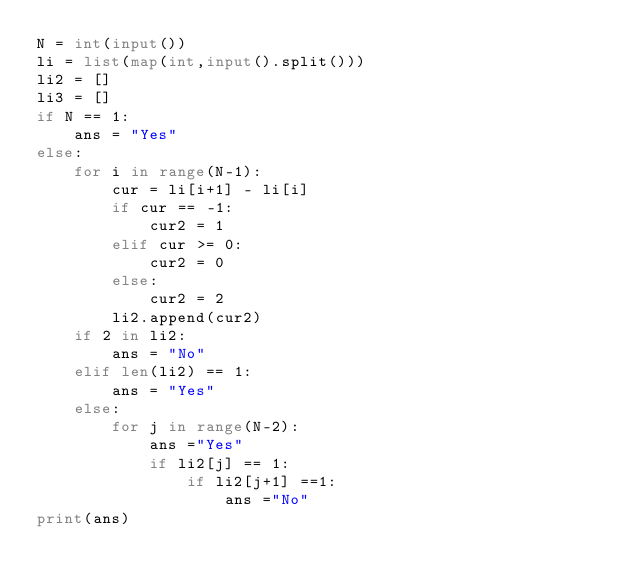<code> <loc_0><loc_0><loc_500><loc_500><_Python_>N = int(input())
li = list(map(int,input().split()))
li2 = []
li3 = []
if N == 1:
    ans = "Yes"
else:
    for i in range(N-1):
        cur = li[i+1] - li[i]
        if cur == -1:
            cur2 = 1
        elif cur >= 0:
            cur2 = 0
        else:
            cur2 = 2
        li2.append(cur2)
    if 2 in li2:
        ans = "No"
    elif len(li2) == 1:
        ans = "Yes"
    else:
        for j in range(N-2):
            ans ="Yes"
            if li2[j] == 1:
                if li2[j+1] ==1:
                    ans ="No"
print(ans)</code> 